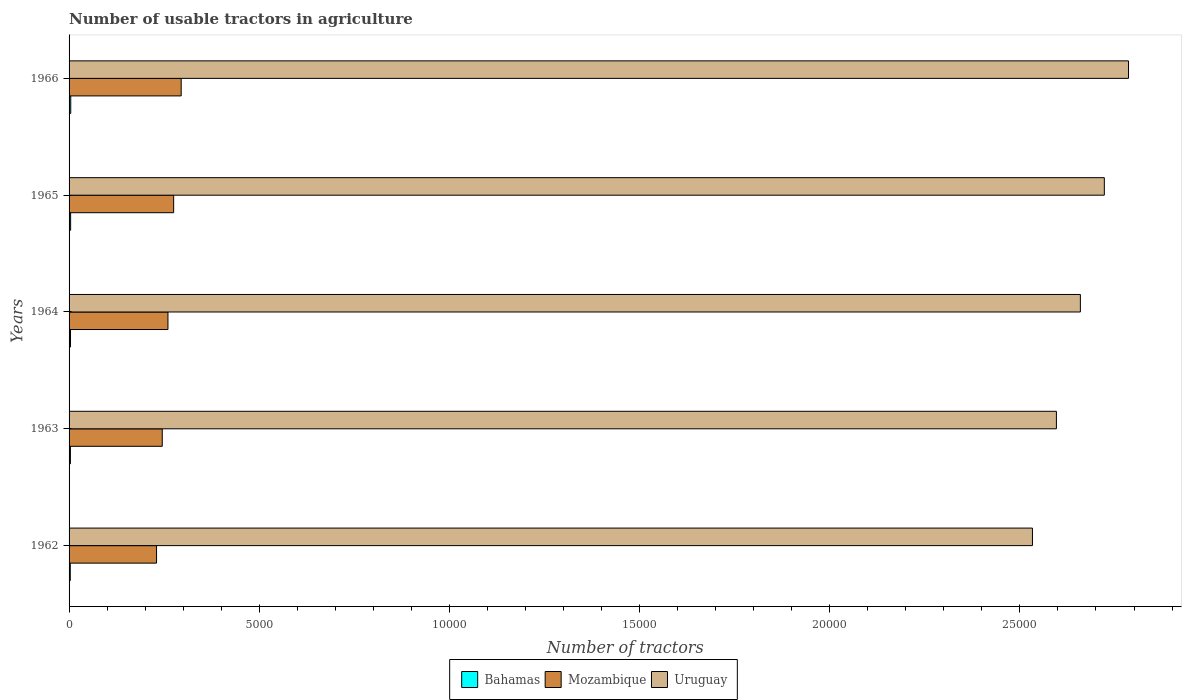How many different coloured bars are there?
Give a very brief answer. 3. Are the number of bars on each tick of the Y-axis equal?
Make the answer very short. Yes. How many bars are there on the 5th tick from the top?
Your answer should be compact. 3. How many bars are there on the 2nd tick from the bottom?
Ensure brevity in your answer.  3. What is the label of the 1st group of bars from the top?
Your answer should be very brief. 1966. In how many cases, is the number of bars for a given year not equal to the number of legend labels?
Your response must be concise. 0. What is the number of usable tractors in agriculture in Bahamas in 1963?
Your answer should be compact. 35. Across all years, what is the minimum number of usable tractors in agriculture in Bahamas?
Ensure brevity in your answer.  32. In which year was the number of usable tractors in agriculture in Mozambique maximum?
Your answer should be very brief. 1966. What is the total number of usable tractors in agriculture in Uruguay in the graph?
Your answer should be very brief. 1.33e+05. What is the difference between the number of usable tractors in agriculture in Bahamas in 1964 and that in 1965?
Provide a succinct answer. -3. What is the difference between the number of usable tractors in agriculture in Mozambique in 1965 and the number of usable tractors in agriculture in Bahamas in 1963?
Your response must be concise. 2715. What is the average number of usable tractors in agriculture in Mozambique per year?
Keep it short and to the point. 2609.6. In the year 1963, what is the difference between the number of usable tractors in agriculture in Uruguay and number of usable tractors in agriculture in Mozambique?
Offer a very short reply. 2.35e+04. What is the ratio of the number of usable tractors in agriculture in Mozambique in 1962 to that in 1964?
Offer a terse response. 0.88. What is the difference between the highest and the second highest number of usable tractors in agriculture in Mozambique?
Offer a terse response. 198. What is the difference between the highest and the lowest number of usable tractors in agriculture in Bahamas?
Provide a short and direct response. 12. In how many years, is the number of usable tractors in agriculture in Uruguay greater than the average number of usable tractors in agriculture in Uruguay taken over all years?
Provide a short and direct response. 2. Is the sum of the number of usable tractors in agriculture in Uruguay in 1964 and 1965 greater than the maximum number of usable tractors in agriculture in Bahamas across all years?
Offer a very short reply. Yes. What does the 3rd bar from the top in 1963 represents?
Make the answer very short. Bahamas. What does the 3rd bar from the bottom in 1963 represents?
Provide a short and direct response. Uruguay. Is it the case that in every year, the sum of the number of usable tractors in agriculture in Bahamas and number of usable tractors in agriculture in Uruguay is greater than the number of usable tractors in agriculture in Mozambique?
Keep it short and to the point. Yes. Are all the bars in the graph horizontal?
Your answer should be compact. Yes. What is the difference between two consecutive major ticks on the X-axis?
Ensure brevity in your answer.  5000. Where does the legend appear in the graph?
Your answer should be very brief. Bottom center. How many legend labels are there?
Offer a very short reply. 3. How are the legend labels stacked?
Provide a succinct answer. Horizontal. What is the title of the graph?
Provide a succinct answer. Number of usable tractors in agriculture. Does "Malawi" appear as one of the legend labels in the graph?
Keep it short and to the point. No. What is the label or title of the X-axis?
Your answer should be very brief. Number of tractors. What is the Number of tractors of Mozambique in 1962?
Your answer should be very brief. 2300. What is the Number of tractors of Uruguay in 1962?
Your answer should be very brief. 2.53e+04. What is the Number of tractors of Mozambique in 1963?
Offer a very short reply. 2450. What is the Number of tractors in Uruguay in 1963?
Keep it short and to the point. 2.60e+04. What is the Number of tractors of Bahamas in 1964?
Make the answer very short. 38. What is the Number of tractors of Mozambique in 1964?
Provide a short and direct response. 2600. What is the Number of tractors in Uruguay in 1964?
Give a very brief answer. 2.66e+04. What is the Number of tractors in Bahamas in 1965?
Offer a very short reply. 41. What is the Number of tractors in Mozambique in 1965?
Offer a terse response. 2750. What is the Number of tractors in Uruguay in 1965?
Your answer should be very brief. 2.72e+04. What is the Number of tractors of Mozambique in 1966?
Make the answer very short. 2948. What is the Number of tractors in Uruguay in 1966?
Keep it short and to the point. 2.79e+04. Across all years, what is the maximum Number of tractors in Mozambique?
Your response must be concise. 2948. Across all years, what is the maximum Number of tractors of Uruguay?
Offer a very short reply. 2.79e+04. Across all years, what is the minimum Number of tractors in Bahamas?
Ensure brevity in your answer.  32. Across all years, what is the minimum Number of tractors in Mozambique?
Make the answer very short. 2300. Across all years, what is the minimum Number of tractors in Uruguay?
Provide a short and direct response. 2.53e+04. What is the total Number of tractors of Bahamas in the graph?
Ensure brevity in your answer.  190. What is the total Number of tractors in Mozambique in the graph?
Provide a short and direct response. 1.30e+04. What is the total Number of tractors in Uruguay in the graph?
Provide a succinct answer. 1.33e+05. What is the difference between the Number of tractors in Bahamas in 1962 and that in 1963?
Ensure brevity in your answer.  -3. What is the difference between the Number of tractors in Mozambique in 1962 and that in 1963?
Your response must be concise. -150. What is the difference between the Number of tractors of Uruguay in 1962 and that in 1963?
Keep it short and to the point. -630. What is the difference between the Number of tractors in Bahamas in 1962 and that in 1964?
Your response must be concise. -6. What is the difference between the Number of tractors of Mozambique in 1962 and that in 1964?
Your response must be concise. -300. What is the difference between the Number of tractors of Uruguay in 1962 and that in 1964?
Your answer should be very brief. -1260. What is the difference between the Number of tractors of Mozambique in 1962 and that in 1965?
Your answer should be very brief. -450. What is the difference between the Number of tractors of Uruguay in 1962 and that in 1965?
Your response must be concise. -1890. What is the difference between the Number of tractors of Bahamas in 1962 and that in 1966?
Offer a terse response. -12. What is the difference between the Number of tractors in Mozambique in 1962 and that in 1966?
Your answer should be compact. -648. What is the difference between the Number of tractors of Uruguay in 1962 and that in 1966?
Make the answer very short. -2526. What is the difference between the Number of tractors of Bahamas in 1963 and that in 1964?
Offer a terse response. -3. What is the difference between the Number of tractors in Mozambique in 1963 and that in 1964?
Offer a terse response. -150. What is the difference between the Number of tractors of Uruguay in 1963 and that in 1964?
Make the answer very short. -630. What is the difference between the Number of tractors in Mozambique in 1963 and that in 1965?
Your answer should be very brief. -300. What is the difference between the Number of tractors in Uruguay in 1963 and that in 1965?
Offer a very short reply. -1260. What is the difference between the Number of tractors in Mozambique in 1963 and that in 1966?
Give a very brief answer. -498. What is the difference between the Number of tractors of Uruguay in 1963 and that in 1966?
Ensure brevity in your answer.  -1896. What is the difference between the Number of tractors in Bahamas in 1964 and that in 1965?
Provide a succinct answer. -3. What is the difference between the Number of tractors of Mozambique in 1964 and that in 1965?
Offer a very short reply. -150. What is the difference between the Number of tractors of Uruguay in 1964 and that in 1965?
Keep it short and to the point. -630. What is the difference between the Number of tractors of Mozambique in 1964 and that in 1966?
Keep it short and to the point. -348. What is the difference between the Number of tractors of Uruguay in 1964 and that in 1966?
Make the answer very short. -1266. What is the difference between the Number of tractors of Mozambique in 1965 and that in 1966?
Provide a succinct answer. -198. What is the difference between the Number of tractors in Uruguay in 1965 and that in 1966?
Make the answer very short. -636. What is the difference between the Number of tractors in Bahamas in 1962 and the Number of tractors in Mozambique in 1963?
Provide a short and direct response. -2418. What is the difference between the Number of tractors in Bahamas in 1962 and the Number of tractors in Uruguay in 1963?
Offer a terse response. -2.59e+04. What is the difference between the Number of tractors of Mozambique in 1962 and the Number of tractors of Uruguay in 1963?
Ensure brevity in your answer.  -2.37e+04. What is the difference between the Number of tractors of Bahamas in 1962 and the Number of tractors of Mozambique in 1964?
Give a very brief answer. -2568. What is the difference between the Number of tractors in Bahamas in 1962 and the Number of tractors in Uruguay in 1964?
Your answer should be compact. -2.66e+04. What is the difference between the Number of tractors in Mozambique in 1962 and the Number of tractors in Uruguay in 1964?
Provide a short and direct response. -2.43e+04. What is the difference between the Number of tractors of Bahamas in 1962 and the Number of tractors of Mozambique in 1965?
Keep it short and to the point. -2718. What is the difference between the Number of tractors of Bahamas in 1962 and the Number of tractors of Uruguay in 1965?
Ensure brevity in your answer.  -2.72e+04. What is the difference between the Number of tractors in Mozambique in 1962 and the Number of tractors in Uruguay in 1965?
Your answer should be compact. -2.49e+04. What is the difference between the Number of tractors of Bahamas in 1962 and the Number of tractors of Mozambique in 1966?
Provide a short and direct response. -2916. What is the difference between the Number of tractors of Bahamas in 1962 and the Number of tractors of Uruguay in 1966?
Make the answer very short. -2.78e+04. What is the difference between the Number of tractors of Mozambique in 1962 and the Number of tractors of Uruguay in 1966?
Provide a short and direct response. -2.56e+04. What is the difference between the Number of tractors in Bahamas in 1963 and the Number of tractors in Mozambique in 1964?
Make the answer very short. -2565. What is the difference between the Number of tractors in Bahamas in 1963 and the Number of tractors in Uruguay in 1964?
Keep it short and to the point. -2.66e+04. What is the difference between the Number of tractors of Mozambique in 1963 and the Number of tractors of Uruguay in 1964?
Ensure brevity in your answer.  -2.41e+04. What is the difference between the Number of tractors of Bahamas in 1963 and the Number of tractors of Mozambique in 1965?
Provide a short and direct response. -2715. What is the difference between the Number of tractors in Bahamas in 1963 and the Number of tractors in Uruguay in 1965?
Provide a short and direct response. -2.72e+04. What is the difference between the Number of tractors of Mozambique in 1963 and the Number of tractors of Uruguay in 1965?
Offer a terse response. -2.48e+04. What is the difference between the Number of tractors of Bahamas in 1963 and the Number of tractors of Mozambique in 1966?
Ensure brevity in your answer.  -2913. What is the difference between the Number of tractors in Bahamas in 1963 and the Number of tractors in Uruguay in 1966?
Provide a short and direct response. -2.78e+04. What is the difference between the Number of tractors in Mozambique in 1963 and the Number of tractors in Uruguay in 1966?
Keep it short and to the point. -2.54e+04. What is the difference between the Number of tractors in Bahamas in 1964 and the Number of tractors in Mozambique in 1965?
Your answer should be very brief. -2712. What is the difference between the Number of tractors of Bahamas in 1964 and the Number of tractors of Uruguay in 1965?
Your answer should be very brief. -2.72e+04. What is the difference between the Number of tractors in Mozambique in 1964 and the Number of tractors in Uruguay in 1965?
Provide a succinct answer. -2.46e+04. What is the difference between the Number of tractors of Bahamas in 1964 and the Number of tractors of Mozambique in 1966?
Your response must be concise. -2910. What is the difference between the Number of tractors of Bahamas in 1964 and the Number of tractors of Uruguay in 1966?
Your answer should be compact. -2.78e+04. What is the difference between the Number of tractors of Mozambique in 1964 and the Number of tractors of Uruguay in 1966?
Give a very brief answer. -2.53e+04. What is the difference between the Number of tractors of Bahamas in 1965 and the Number of tractors of Mozambique in 1966?
Your answer should be compact. -2907. What is the difference between the Number of tractors in Bahamas in 1965 and the Number of tractors in Uruguay in 1966?
Provide a short and direct response. -2.78e+04. What is the difference between the Number of tractors of Mozambique in 1965 and the Number of tractors of Uruguay in 1966?
Provide a succinct answer. -2.51e+04. What is the average Number of tractors of Mozambique per year?
Your answer should be very brief. 2609.6. What is the average Number of tractors in Uruguay per year?
Offer a very short reply. 2.66e+04. In the year 1962, what is the difference between the Number of tractors in Bahamas and Number of tractors in Mozambique?
Your answer should be compact. -2268. In the year 1962, what is the difference between the Number of tractors in Bahamas and Number of tractors in Uruguay?
Your answer should be compact. -2.53e+04. In the year 1962, what is the difference between the Number of tractors in Mozambique and Number of tractors in Uruguay?
Provide a short and direct response. -2.30e+04. In the year 1963, what is the difference between the Number of tractors of Bahamas and Number of tractors of Mozambique?
Give a very brief answer. -2415. In the year 1963, what is the difference between the Number of tractors in Bahamas and Number of tractors in Uruguay?
Offer a very short reply. -2.59e+04. In the year 1963, what is the difference between the Number of tractors of Mozambique and Number of tractors of Uruguay?
Keep it short and to the point. -2.35e+04. In the year 1964, what is the difference between the Number of tractors in Bahamas and Number of tractors in Mozambique?
Ensure brevity in your answer.  -2562. In the year 1964, what is the difference between the Number of tractors in Bahamas and Number of tractors in Uruguay?
Your answer should be very brief. -2.66e+04. In the year 1964, what is the difference between the Number of tractors in Mozambique and Number of tractors in Uruguay?
Your response must be concise. -2.40e+04. In the year 1965, what is the difference between the Number of tractors of Bahamas and Number of tractors of Mozambique?
Make the answer very short. -2709. In the year 1965, what is the difference between the Number of tractors of Bahamas and Number of tractors of Uruguay?
Offer a very short reply. -2.72e+04. In the year 1965, what is the difference between the Number of tractors of Mozambique and Number of tractors of Uruguay?
Give a very brief answer. -2.45e+04. In the year 1966, what is the difference between the Number of tractors of Bahamas and Number of tractors of Mozambique?
Offer a very short reply. -2904. In the year 1966, what is the difference between the Number of tractors of Bahamas and Number of tractors of Uruguay?
Ensure brevity in your answer.  -2.78e+04. In the year 1966, what is the difference between the Number of tractors of Mozambique and Number of tractors of Uruguay?
Your answer should be very brief. -2.49e+04. What is the ratio of the Number of tractors in Bahamas in 1962 to that in 1963?
Your answer should be very brief. 0.91. What is the ratio of the Number of tractors in Mozambique in 1962 to that in 1963?
Keep it short and to the point. 0.94. What is the ratio of the Number of tractors in Uruguay in 1962 to that in 1963?
Give a very brief answer. 0.98. What is the ratio of the Number of tractors in Bahamas in 1962 to that in 1964?
Provide a succinct answer. 0.84. What is the ratio of the Number of tractors in Mozambique in 1962 to that in 1964?
Keep it short and to the point. 0.88. What is the ratio of the Number of tractors of Uruguay in 1962 to that in 1964?
Provide a succinct answer. 0.95. What is the ratio of the Number of tractors of Bahamas in 1962 to that in 1965?
Offer a very short reply. 0.78. What is the ratio of the Number of tractors of Mozambique in 1962 to that in 1965?
Offer a very short reply. 0.84. What is the ratio of the Number of tractors in Uruguay in 1962 to that in 1965?
Keep it short and to the point. 0.93. What is the ratio of the Number of tractors of Bahamas in 1962 to that in 1966?
Provide a short and direct response. 0.73. What is the ratio of the Number of tractors of Mozambique in 1962 to that in 1966?
Provide a succinct answer. 0.78. What is the ratio of the Number of tractors in Uruguay in 1962 to that in 1966?
Make the answer very short. 0.91. What is the ratio of the Number of tractors in Bahamas in 1963 to that in 1964?
Ensure brevity in your answer.  0.92. What is the ratio of the Number of tractors of Mozambique in 1963 to that in 1964?
Provide a succinct answer. 0.94. What is the ratio of the Number of tractors of Uruguay in 1963 to that in 1964?
Offer a terse response. 0.98. What is the ratio of the Number of tractors of Bahamas in 1963 to that in 1965?
Ensure brevity in your answer.  0.85. What is the ratio of the Number of tractors in Mozambique in 1963 to that in 1965?
Give a very brief answer. 0.89. What is the ratio of the Number of tractors of Uruguay in 1963 to that in 1965?
Keep it short and to the point. 0.95. What is the ratio of the Number of tractors of Bahamas in 1963 to that in 1966?
Make the answer very short. 0.8. What is the ratio of the Number of tractors of Mozambique in 1963 to that in 1966?
Make the answer very short. 0.83. What is the ratio of the Number of tractors in Uruguay in 1963 to that in 1966?
Your response must be concise. 0.93. What is the ratio of the Number of tractors of Bahamas in 1964 to that in 1965?
Give a very brief answer. 0.93. What is the ratio of the Number of tractors in Mozambique in 1964 to that in 1965?
Your answer should be compact. 0.95. What is the ratio of the Number of tractors in Uruguay in 1964 to that in 1965?
Provide a short and direct response. 0.98. What is the ratio of the Number of tractors in Bahamas in 1964 to that in 1966?
Offer a terse response. 0.86. What is the ratio of the Number of tractors of Mozambique in 1964 to that in 1966?
Make the answer very short. 0.88. What is the ratio of the Number of tractors in Uruguay in 1964 to that in 1966?
Your answer should be very brief. 0.95. What is the ratio of the Number of tractors in Bahamas in 1965 to that in 1966?
Your answer should be compact. 0.93. What is the ratio of the Number of tractors of Mozambique in 1965 to that in 1966?
Make the answer very short. 0.93. What is the ratio of the Number of tractors in Uruguay in 1965 to that in 1966?
Provide a short and direct response. 0.98. What is the difference between the highest and the second highest Number of tractors of Bahamas?
Offer a very short reply. 3. What is the difference between the highest and the second highest Number of tractors in Mozambique?
Offer a very short reply. 198. What is the difference between the highest and the second highest Number of tractors in Uruguay?
Provide a succinct answer. 636. What is the difference between the highest and the lowest Number of tractors of Bahamas?
Your answer should be very brief. 12. What is the difference between the highest and the lowest Number of tractors of Mozambique?
Your answer should be very brief. 648. What is the difference between the highest and the lowest Number of tractors of Uruguay?
Give a very brief answer. 2526. 